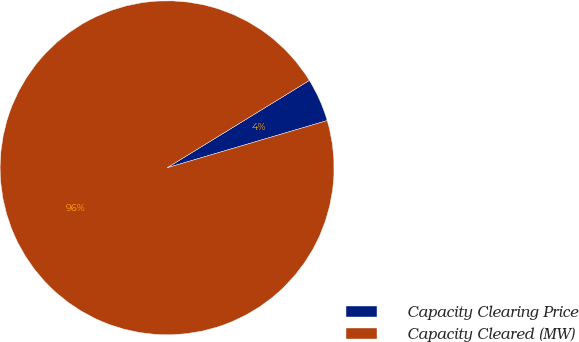Convert chart. <chart><loc_0><loc_0><loc_500><loc_500><pie_chart><fcel>Capacity Clearing Price<fcel>Capacity Cleared (MW)<nl><fcel>4.2%<fcel>95.8%<nl></chart> 